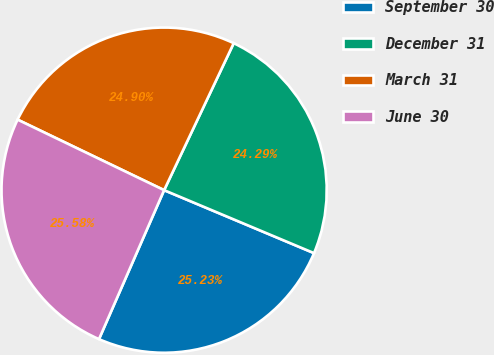Convert chart. <chart><loc_0><loc_0><loc_500><loc_500><pie_chart><fcel>September 30<fcel>December 31<fcel>March 31<fcel>June 30<nl><fcel>25.23%<fcel>24.29%<fcel>24.9%<fcel>25.58%<nl></chart> 